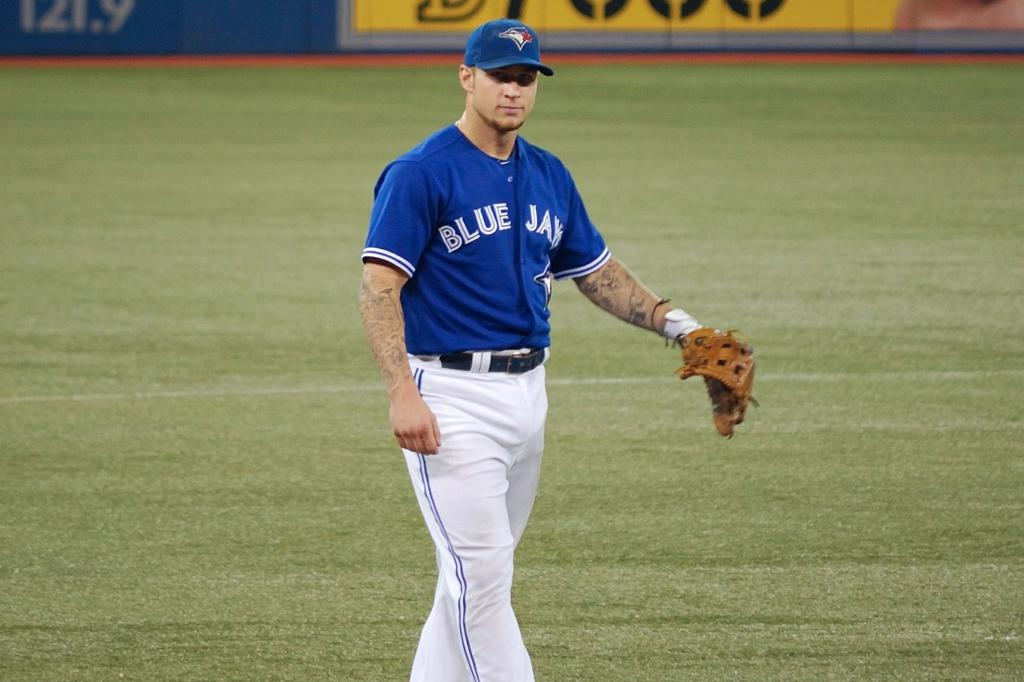<image>
Offer a succinct explanation of the picture presented. a Blue Jays jersey on a person that is on a field 